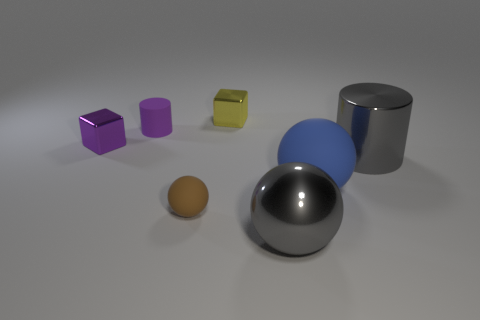Subtract all large blue spheres. How many spheres are left? 2 Add 1 big gray things. How many objects exist? 8 Subtract all brown balls. How many balls are left? 2 Subtract 0 gray cubes. How many objects are left? 7 Subtract all cubes. How many objects are left? 5 Subtract all cyan cubes. Subtract all cyan spheres. How many cubes are left? 2 Subtract all gray cylinders. How many purple blocks are left? 1 Subtract all tiny gray matte spheres. Subtract all tiny brown matte balls. How many objects are left? 6 Add 2 purple metal blocks. How many purple metal blocks are left? 3 Add 7 small purple cylinders. How many small purple cylinders exist? 8 